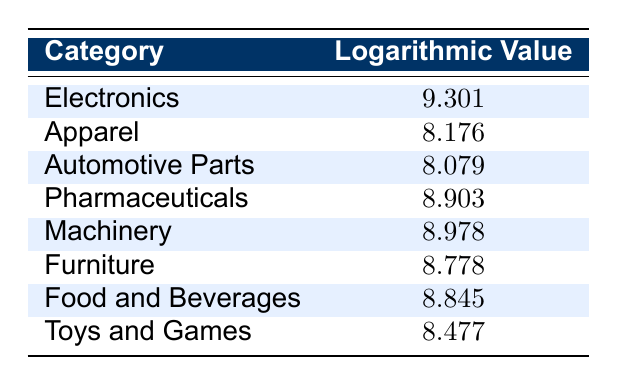What is the logarithmic value for Electronics? The table lists the logarithmic value for the "Electronics" category directly, which is 9.301.
Answer: 9.301 Which category has a logarithmic value closest to 9? By inspecting the table, "Machinery" has a logarithmic value of 8.978, which is the closest to 9 when compared to other categories.
Answer: Machinery Is the logarithmic value for Pharmaceuticals greater than that for Automotive Parts? The logarithmic value for Pharmaceuticals is 8.903 and for Automotive Parts is 8.079. Since 8.903 is greater than 8.079, the statement is true.
Answer: Yes What is the difference between the highest and the lowest logarithmic values in the table? The highest logarithmic value is for "Electronics" at 9.301, and the lowest is for "Automotive Parts" at 8.079. The difference is 9.301 - 8.079 = 1.222.
Answer: 1.222 What is the average logarithmic value of Food and Beverages and Pharmaceuticals? The logarithmic values for Food and Beverages and Pharmaceuticals are 8.845 and 8.903, respectively. Their sum is 8.845 + 8.903 = 17.748, and the average is 17.748 / 2 = 8.874.
Answer: 8.874 Do more categories have logarithmic values above 8.5 than below? The categories with logarithmic values above 8.5 are Electronics, Pharmaceuticals, Machinery, Furniture, and Food and Beverages (5 categories), while Apparel, Automotive Parts, and Toys and Games are below 8.5 (3 categories). Therefore, yes, there are more categories above 8.5.
Answer: Yes What is the sum of the logarithmic values for Apparel and Toys and Games? The logarithmic values are 8.176 for Apparel and 8.477 for Toys and Games. Their sum is 8.176 + 8.477 = 16.653.
Answer: 16.653 Which categories have logarithmic values below 8.5? The categories with logarithmic values below 8.5 are "Apparel" (8.176), "Automotive Parts" (8.079), and "Toys and Games" (8.477).
Answer: Apparel, Automotive Parts, Toys and Games What is the logarithmic value for Machinery compared to that of Food and Beverages? The logarithmic value for Machinery is 8.978 and for Food and Beverages it is 8.845. Therefore, Machinery has a higher logarithmic value than Food and Beverages.
Answer: Machinery is higher 